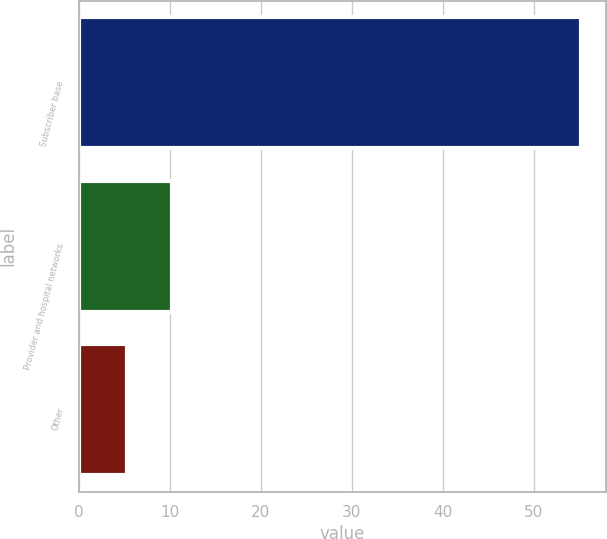<chart> <loc_0><loc_0><loc_500><loc_500><bar_chart><fcel>Subscriber base<fcel>Provider and hospital networks<fcel>Other<nl><fcel>55.2<fcel>10.29<fcel>5.3<nl></chart> 